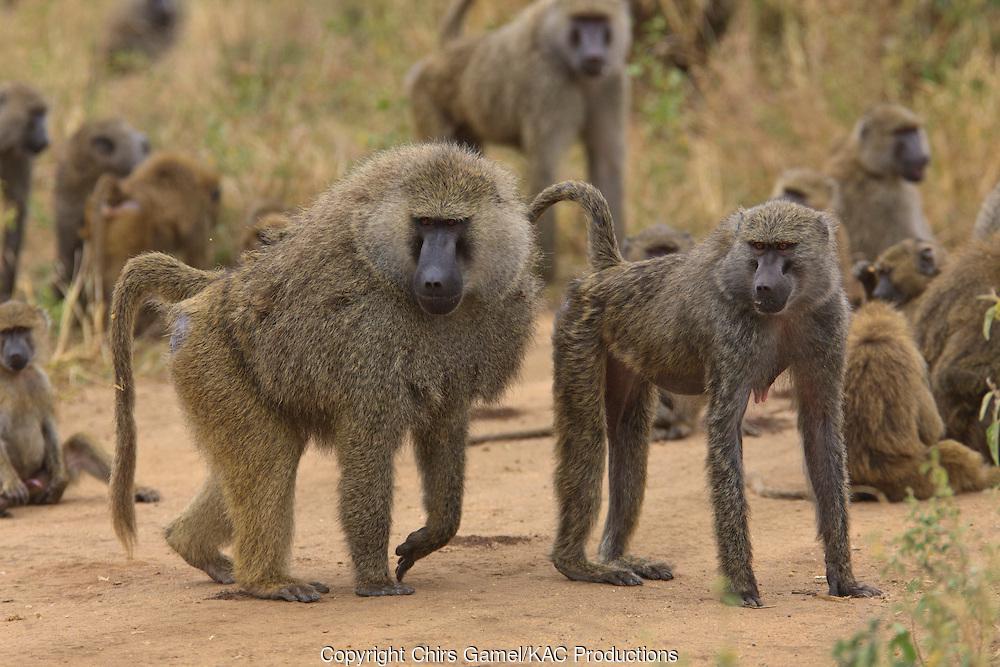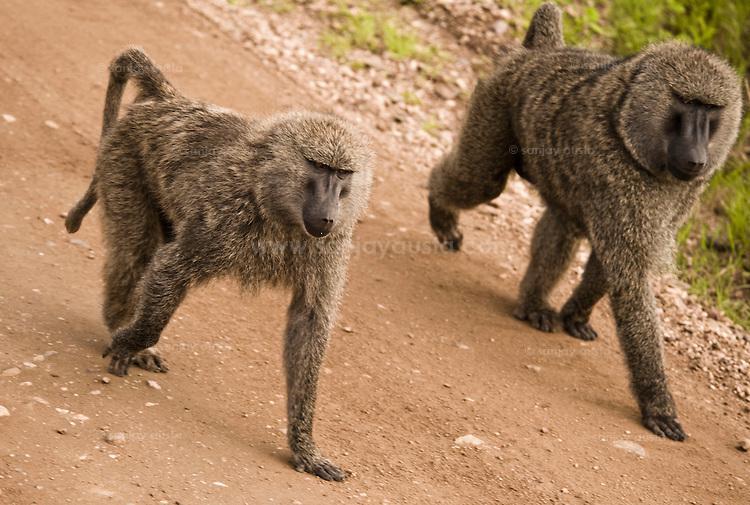The first image is the image on the left, the second image is the image on the right. Evaluate the accuracy of this statement regarding the images: "There are at least three baboons.". Is it true? Answer yes or no. Yes. The first image is the image on the left, the second image is the image on the right. Evaluate the accuracy of this statement regarding the images: "Each image contains a single baboon, and no baboon has a wide-open mouth.". Is it true? Answer yes or no. No. 